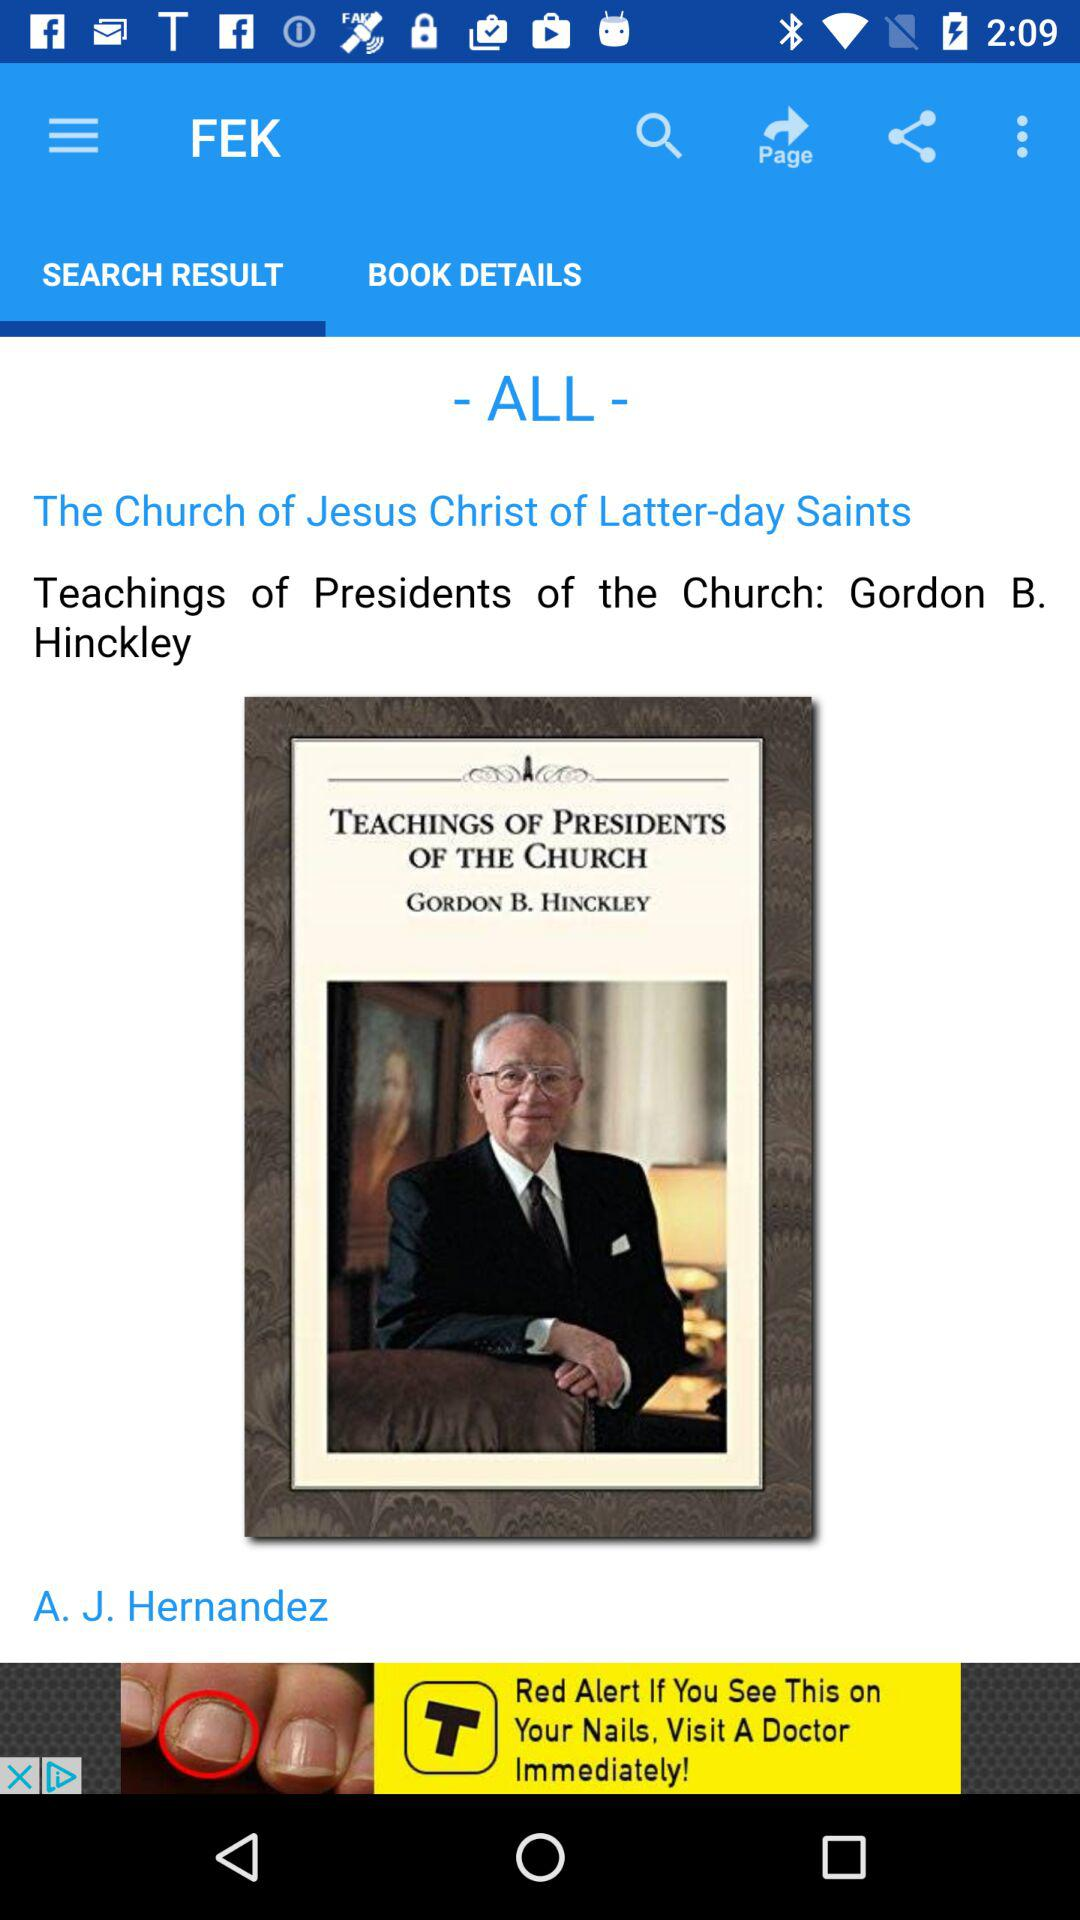Which tab is selected? The selected tab is "SEARCH RESULT". 